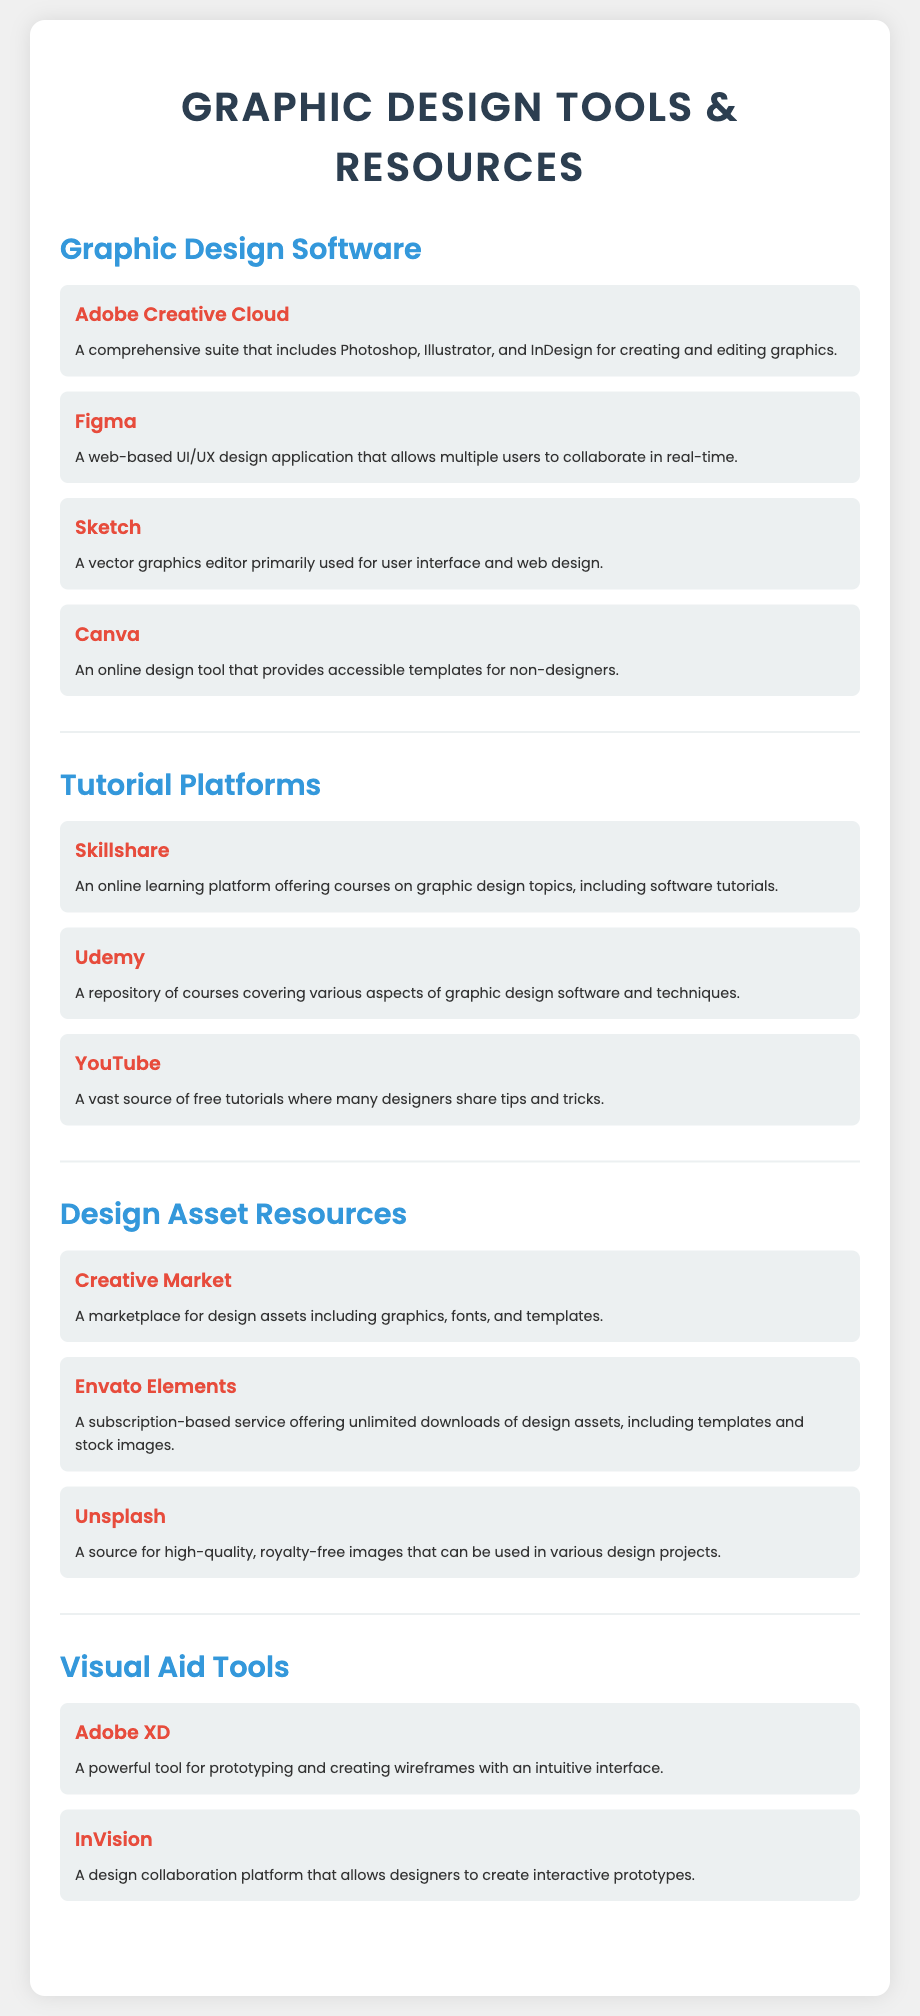what is the title of the document? The title is presented at the top of the document, stating the main topic covered.
Answer: Graphic Design Tools & Resources how many design software are listed? The document enumerates the software under the "Graphic Design Software" section, counting each entry listed.
Answer: 4 what is one of the video platforms mentioned for tutorials? The document lists various tutorial platforms, specifically highlighting one in the item description.
Answer: YouTube which subscription-based service offers unlimited downloads? The document identifies it under the "Design Asset Resources" section, indicating a service related to design assets.
Answer: Envato Elements what tool is described as a powerful prototyping tool? The text refers to this tool in the "Visual Aid Tools" section, discussing its function.
Answer: Adobe XD which design tool is primarily used for UI/UX design? The document specifies this in the description of a listed software item under graphic design software.
Answer: Figma what is the color of the headings in the software section? This question addresses the visual aspect of the document's design regarding the text color used for section headings.
Answer: #3498db how many tutorial platforms are included? By examining the number of items listed under the "Tutorial Platforms" section, we can determine the total.
Answer: 3 what type of resources does Creative Market provide? The document explains what types of design assets are available from this marketplace.
Answer: Design assets 